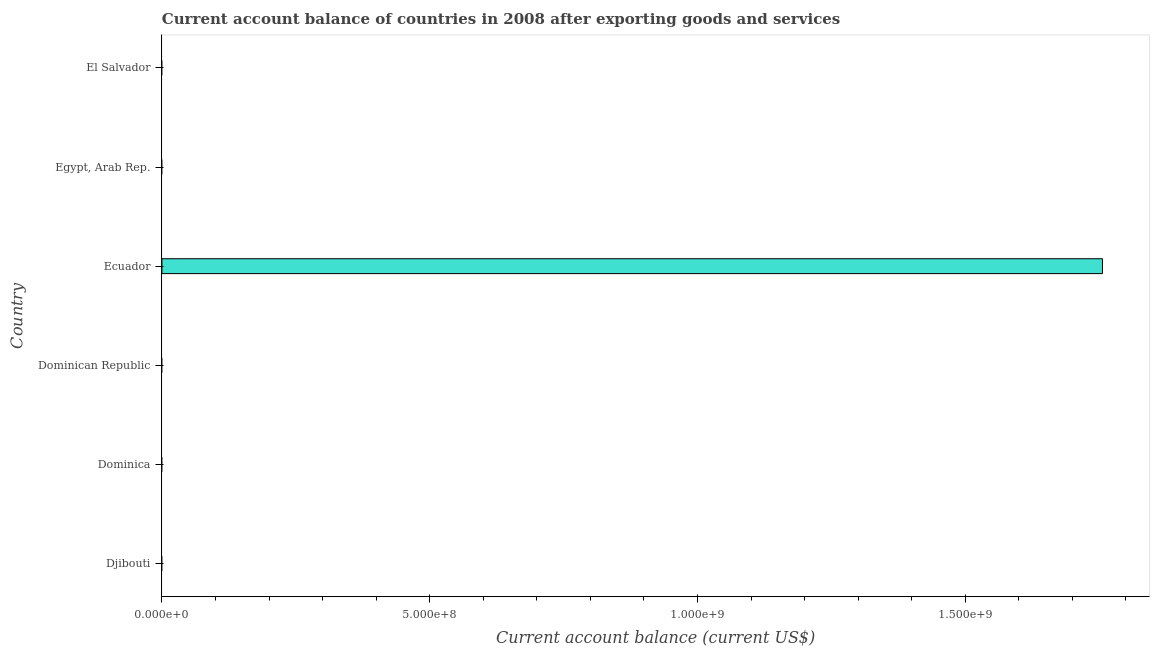Does the graph contain grids?
Offer a terse response. No. What is the title of the graph?
Ensure brevity in your answer.  Current account balance of countries in 2008 after exporting goods and services. What is the label or title of the X-axis?
Offer a very short reply. Current account balance (current US$). What is the label or title of the Y-axis?
Your answer should be very brief. Country. Across all countries, what is the maximum current account balance?
Provide a short and direct response. 1.76e+09. Across all countries, what is the minimum current account balance?
Your answer should be compact. 0. In which country was the current account balance maximum?
Provide a short and direct response. Ecuador. What is the sum of the current account balance?
Offer a terse response. 1.76e+09. What is the average current account balance per country?
Provide a succinct answer. 2.93e+08. What is the difference between the highest and the lowest current account balance?
Offer a terse response. 1.76e+09. In how many countries, is the current account balance greater than the average current account balance taken over all countries?
Provide a succinct answer. 1. How many bars are there?
Offer a terse response. 1. Are all the bars in the graph horizontal?
Make the answer very short. Yes. What is the Current account balance (current US$) of Djibouti?
Give a very brief answer. 0. What is the Current account balance (current US$) of Dominican Republic?
Ensure brevity in your answer.  0. What is the Current account balance (current US$) of Ecuador?
Keep it short and to the point. 1.76e+09. What is the Current account balance (current US$) in El Salvador?
Give a very brief answer. 0. 